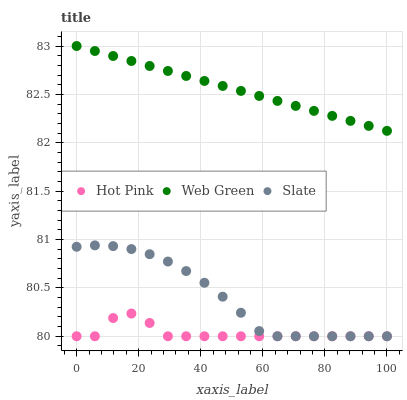Does Hot Pink have the minimum area under the curve?
Answer yes or no. Yes. Does Web Green have the maximum area under the curve?
Answer yes or no. Yes. Does Web Green have the minimum area under the curve?
Answer yes or no. No. Does Hot Pink have the maximum area under the curve?
Answer yes or no. No. Is Web Green the smoothest?
Answer yes or no. Yes. Is Hot Pink the roughest?
Answer yes or no. Yes. Is Hot Pink the smoothest?
Answer yes or no. No. Is Web Green the roughest?
Answer yes or no. No. Does Slate have the lowest value?
Answer yes or no. Yes. Does Web Green have the lowest value?
Answer yes or no. No. Does Web Green have the highest value?
Answer yes or no. Yes. Does Hot Pink have the highest value?
Answer yes or no. No. Is Hot Pink less than Web Green?
Answer yes or no. Yes. Is Web Green greater than Hot Pink?
Answer yes or no. Yes. Does Slate intersect Hot Pink?
Answer yes or no. Yes. Is Slate less than Hot Pink?
Answer yes or no. No. Is Slate greater than Hot Pink?
Answer yes or no. No. Does Hot Pink intersect Web Green?
Answer yes or no. No. 